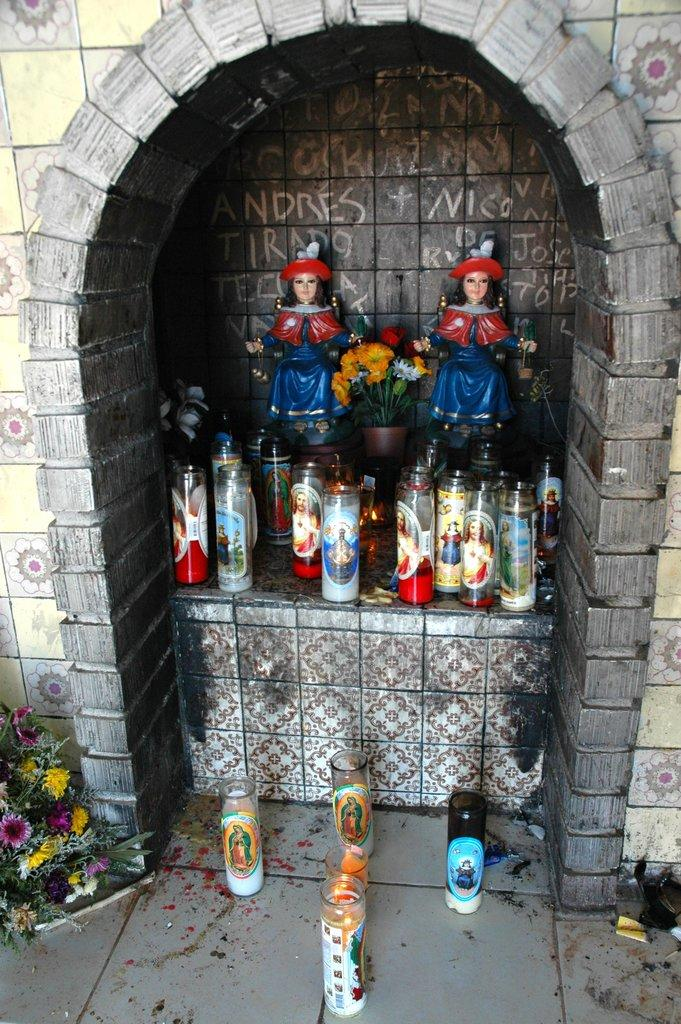How many dolls are present in the image? There are two dolls in the image. What else can be seen in the image besides the dolls? There is a flower vase in the image. What type of cream is being used to decorate the dolls in the image? There is no cream present in the image, nor is it being used to decorate the dolls. 